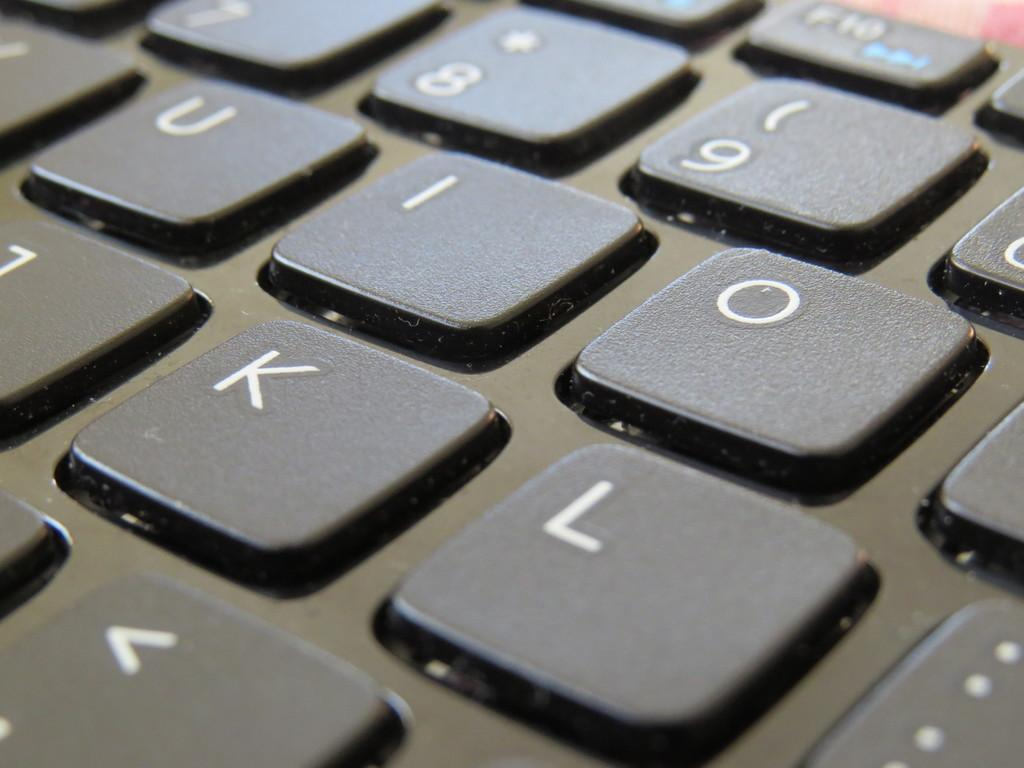<image>
Relay a brief, clear account of the picture shown. A zoomed in picture of keys with I, O, K and L in the focus 